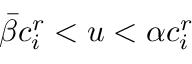<formula> <loc_0><loc_0><loc_500><loc_500>{ \bar { \beta } } c _ { i } ^ { r } < u < \alpha c _ { i } ^ { r }</formula> 